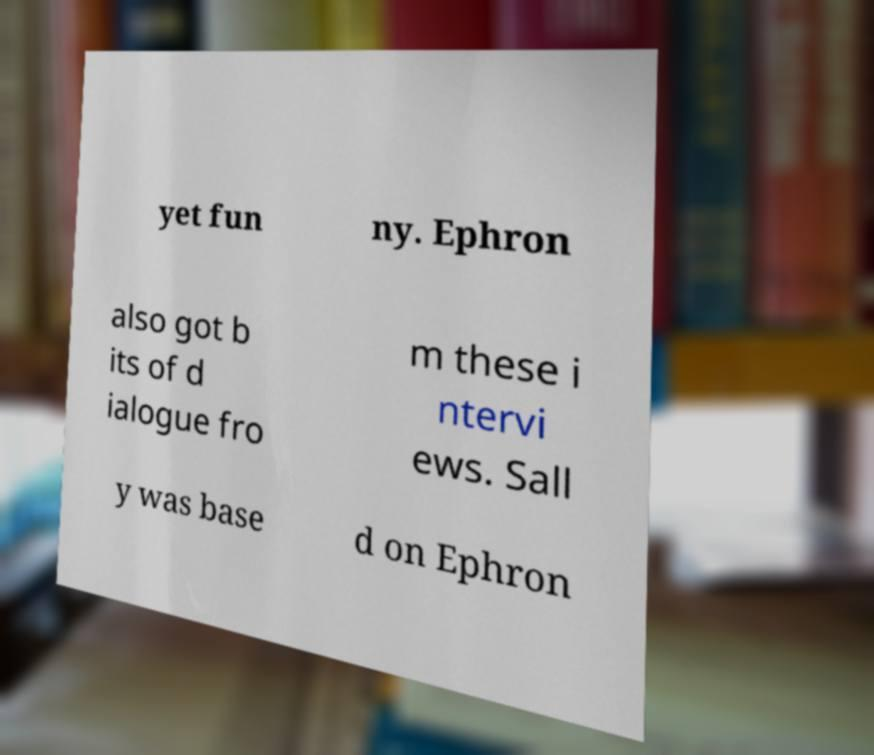Could you extract and type out the text from this image? yet fun ny. Ephron also got b its of d ialogue fro m these i ntervi ews. Sall y was base d on Ephron 